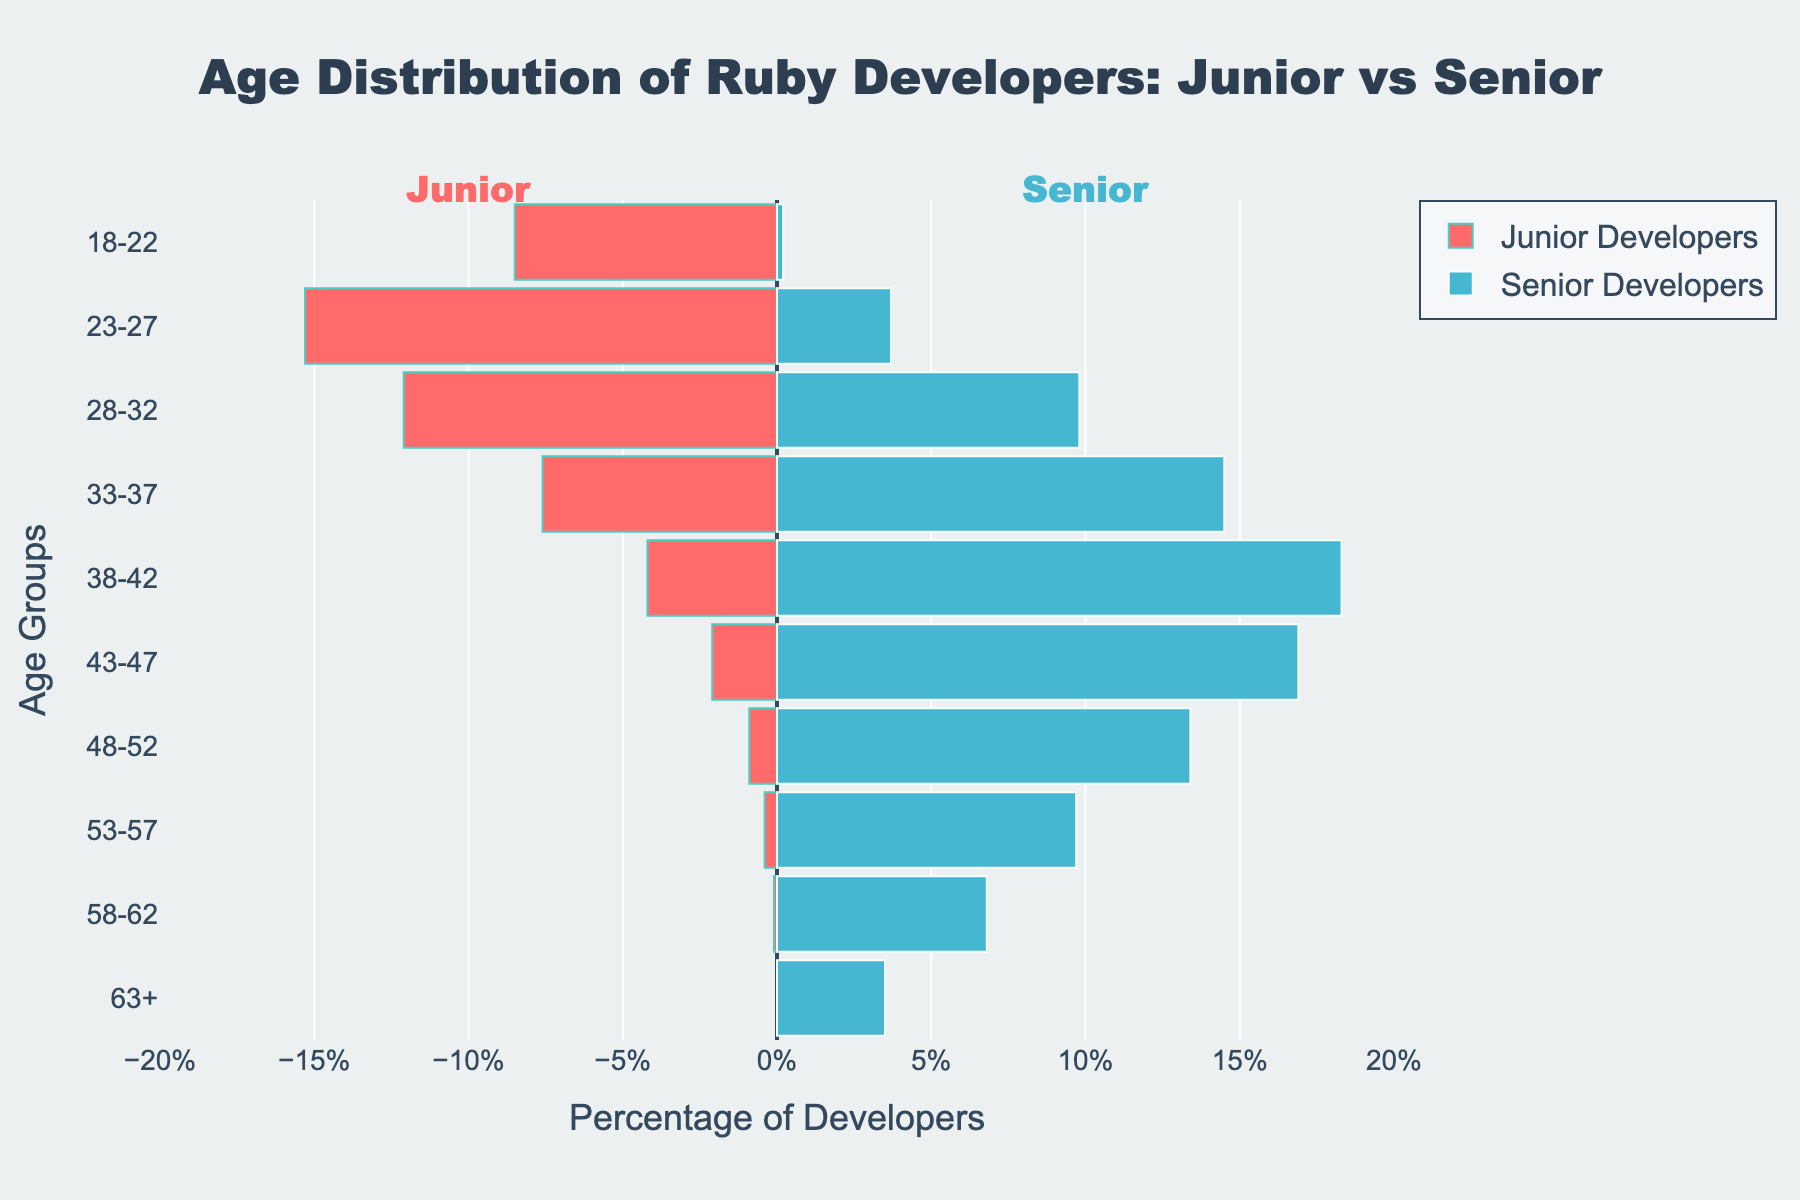How is the age group '23-27' visualized for junior developers? The '23-27' age group for junior developers is represented by a horizontal bar going to the left, colored in a reddish hue. The length of the bar corresponds to approximately 15.3% of the developers in that age group.
Answer: A horizontal reddish bar to the left, approximately 15.3% In which age group do senior developers form the largest percentage? To find the largest percentage for senior developers, observe the blue bars to the right. The longest blue bar stretches out in the '38-42' age group, indicating it has the highest percentage of senior developers.
Answer: '38-42' What is the difference in the percentage of junior developers between the age groups '18-22' and '53-57'? To find the difference, subtract the percentage of junior developers in the '53-57' age group from the percentage in the '18-22' age group. From the figure, the values are 8.5% and 0.4%, respectively. Therefore, 8.5% - 0.4% = 8.1%.
Answer: 8.1% Compare the percentage of junior developers in the '28-32' age group to senior developers in the same group. Both values are found by looking at the bar lengths in the '28-32' age group. Junior developers represent 12.1%, while senior developers represent 9.8%. By comparison, 12.1% is greater than 9.8%.
Answer: Junior developers have a higher percentage (12.1%) compared to senior developers (9.8%) How many age groups have more than 10% of senior developers? To determine this, identify the age groups where the blue bars exceed 10%. Observing the bars, the groups are '28-32', '33-37', '38-42', '43-47', and '48-52'. Counting these groups results in five age groups.
Answer: 5 What is the combined percentage of developers aged '38-42' across both junior and senior roles? The problem requires adding the percentages of both junior and senior developers in the '38-42' age group. From the figure, the values are 4.2% for juniors and 18.3% for seniors. Summing these gives 4.2% + 18.3% = 22.5%.
Answer: 22.5% Which age group shows the least percentage of junior developers and what is the value? Examine the left side of the figure for junior developers' bars and find the shortest one, which appears in the '63+' age group. The figure indicates this percentage is 0.0%.
Answer: '63+' with 0.0% Which direction (left or right) do the bars extend for senior developers compared to junior developers? The bars for senior developers extend to the right, while the bars for junior developers extend to the left. This can be seen by the general orientation of each bar group on the respective sides of the zero line.
Answer: Right for seniors and left for juniors 